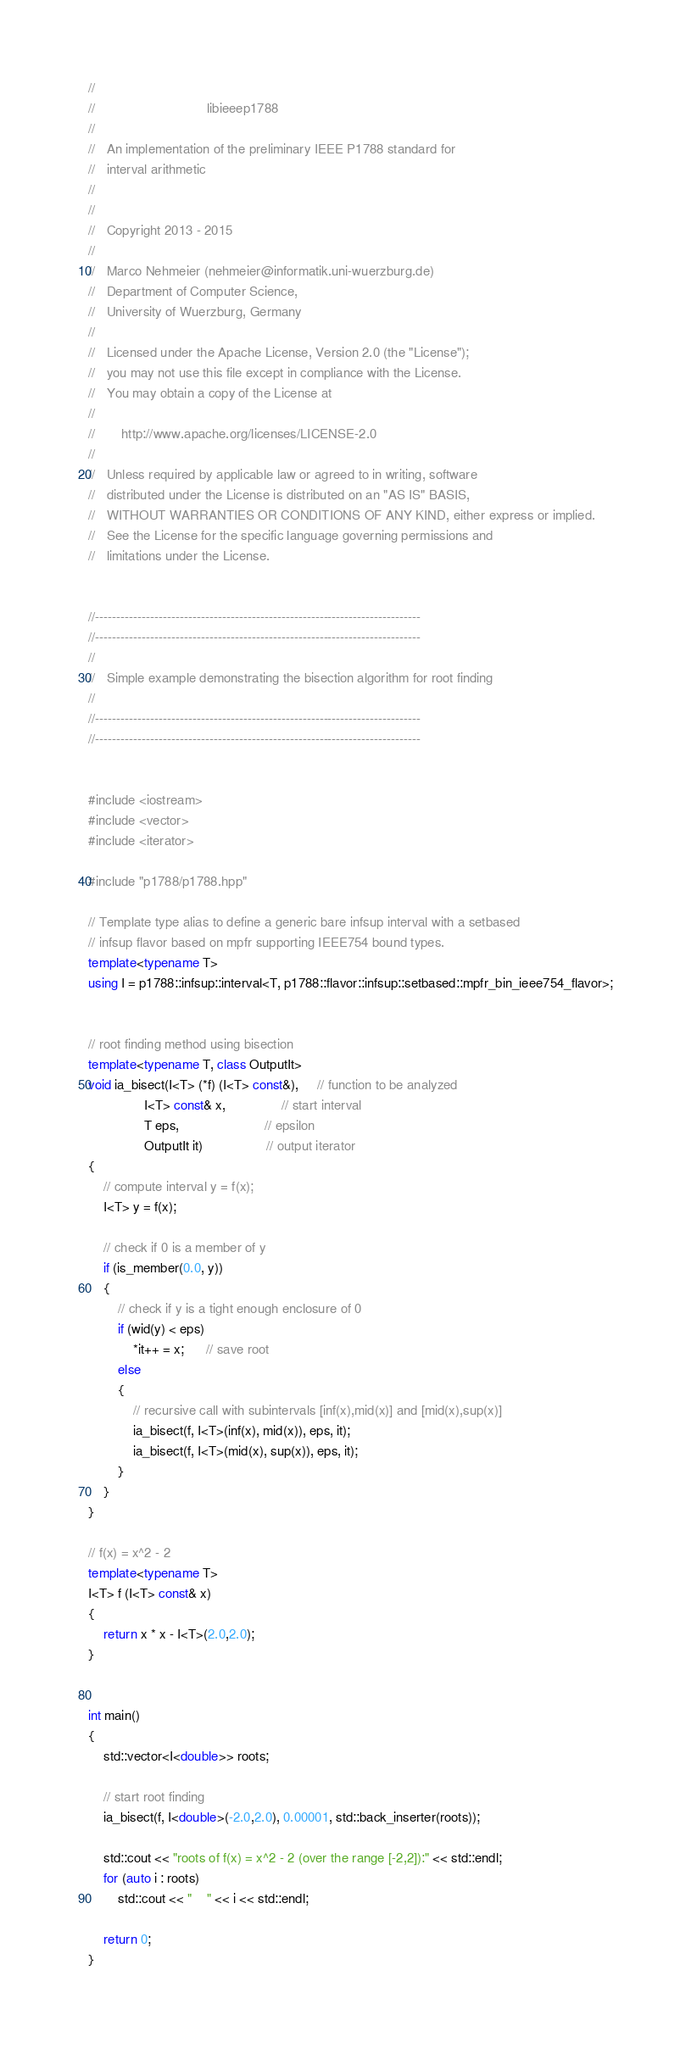<code> <loc_0><loc_0><loc_500><loc_500><_C++_>//
//                              libieeep1788
//
//   An implementation of the preliminary IEEE P1788 standard for
//   interval arithmetic
//
//
//   Copyright 2013 - 2015
//
//   Marco Nehmeier (nehmeier@informatik.uni-wuerzburg.de)
//   Department of Computer Science,
//   University of Wuerzburg, Germany
//
//   Licensed under the Apache License, Version 2.0 (the "License");
//   you may not use this file except in compliance with the License.
//   You may obtain a copy of the License at
//
//       http://www.apache.org/licenses/LICENSE-2.0
//
//   Unless required by applicable law or agreed to in writing, software
//   distributed under the License is distributed on an "AS IS" BASIS,
//   WITHOUT WARRANTIES OR CONDITIONS OF ANY KIND, either express or implied.
//   See the License for the specific language governing permissions and
//   limitations under the License.


//-----------------------------------------------------------------------------
//-----------------------------------------------------------------------------
//
//   Simple example demonstrating the bisection algorithm for root finding
//
//-----------------------------------------------------------------------------
//-----------------------------------------------------------------------------


#include <iostream>
#include <vector>
#include <iterator>

#include "p1788/p1788.hpp"

// Template type alias to define a generic bare infsup interval with a setbased
// infsup flavor based on mpfr supporting IEEE754 bound types.
template<typename T>
using I = p1788::infsup::interval<T, p1788::flavor::infsup::setbased::mpfr_bin_ieee754_flavor>;


// root finding method using bisection
template<typename T, class OutputIt>
void ia_bisect(I<T> (*f) (I<T> const&),     // function to be analyzed
               I<T> const& x,               // start interval
               T eps,                       // epsilon
               OutputIt it)                 // output iterator
{
    // compute interval y = f(x);
    I<T> y = f(x);

    // check if 0 is a member of y
    if (is_member(0.0, y))
    {
        // check if y is a tight enough enclosure of 0
        if (wid(y) < eps)
            *it++ = x;      // save root
        else
        {
            // recursive call with subintervals [inf(x),mid(x)] and [mid(x),sup(x)]
            ia_bisect(f, I<T>(inf(x), mid(x)), eps, it);
            ia_bisect(f, I<T>(mid(x), sup(x)), eps, it);
        }
    }
}

// f(x) = x^2 - 2
template<typename T>
I<T> f (I<T> const& x)
{
    return x * x - I<T>(2.0,2.0);
}


int main()
{
    std::vector<I<double>> roots;

    // start root finding
    ia_bisect(f, I<double>(-2.0,2.0), 0.00001, std::back_inserter(roots));

    std::cout << "roots of f(x) = x^2 - 2 (over the range [-2,2]):" << std::endl;
    for (auto i : roots)
        std::cout << "    " << i << std::endl;

    return 0;
}

</code> 